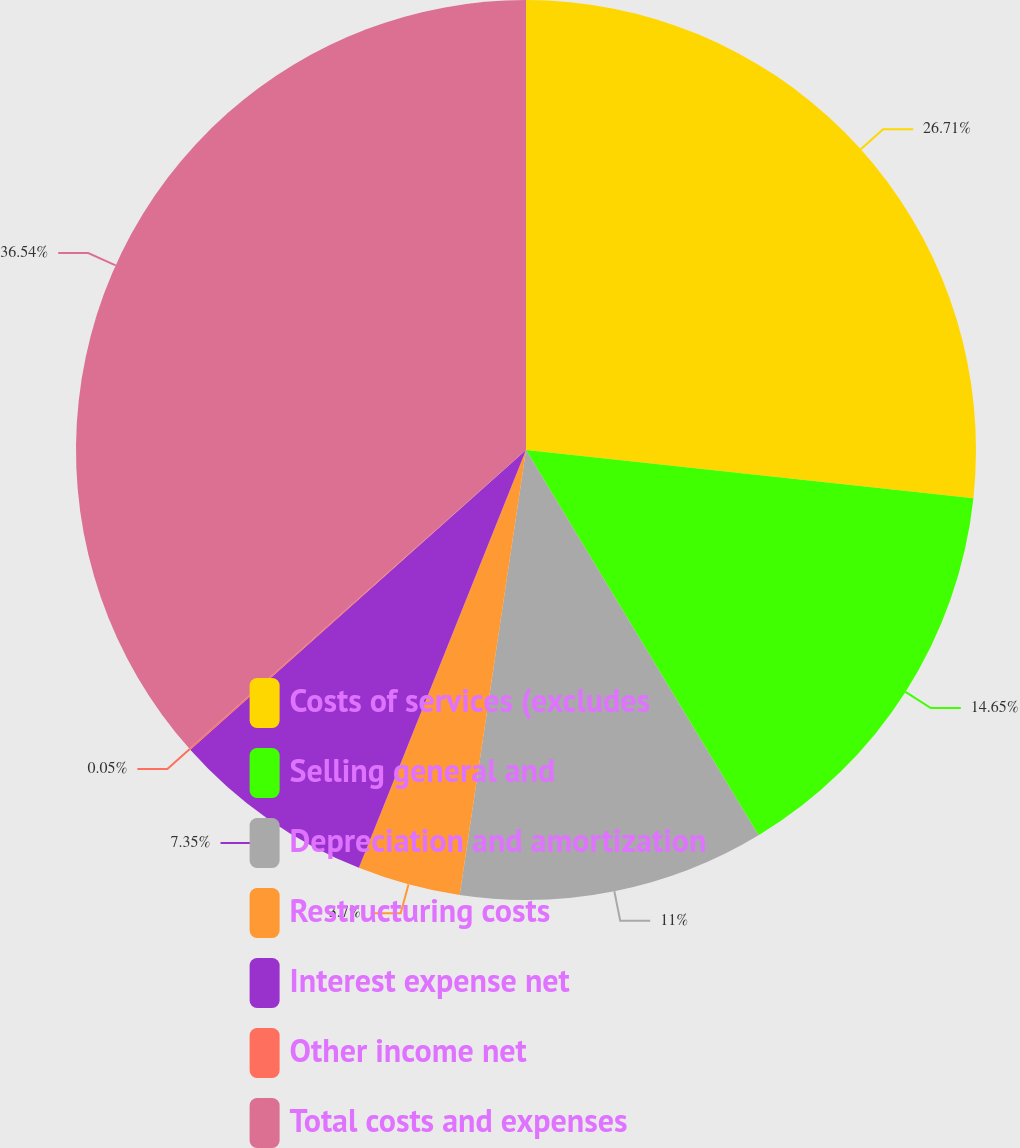Convert chart. <chart><loc_0><loc_0><loc_500><loc_500><pie_chart><fcel>Costs of services (excludes<fcel>Selling general and<fcel>Depreciation and amortization<fcel>Restructuring costs<fcel>Interest expense net<fcel>Other income net<fcel>Total costs and expenses<nl><fcel>26.71%<fcel>14.65%<fcel>11.0%<fcel>3.7%<fcel>7.35%<fcel>0.05%<fcel>36.55%<nl></chart> 